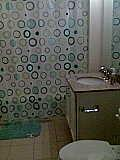Question: what rooms is this?
Choices:
A. Den.
B. Bedroom.
C. Kitchen.
D. Bathroom.
Answer with the letter. Answer: D Question: when on the toilet, what is to the right?
Choices:
A. Shower.
B. Sink.
C. Cabinet.
D. Tub.
Answer with the letter. Answer: B Question: who uses the bathroom?
Choices:
A. Animals.
B. People.
C. Robots.
D. Aliens.
Answer with the letter. Answer: B Question: why is there a rug?
Choices:
A. To hide something.
B. To stand on.
C. To cool the room.
D. To prevent fire.
Answer with the letter. Answer: B Question: how many toilets are there?
Choices:
A. One.
B. Two.
C. Three.
D. Four.
Answer with the letter. Answer: A Question: what design is on the shower curtain?
Choices:
A. Squares.
B. Paisley.
C. Circles.
D. Plaid.
Answer with the letter. Answer: C 